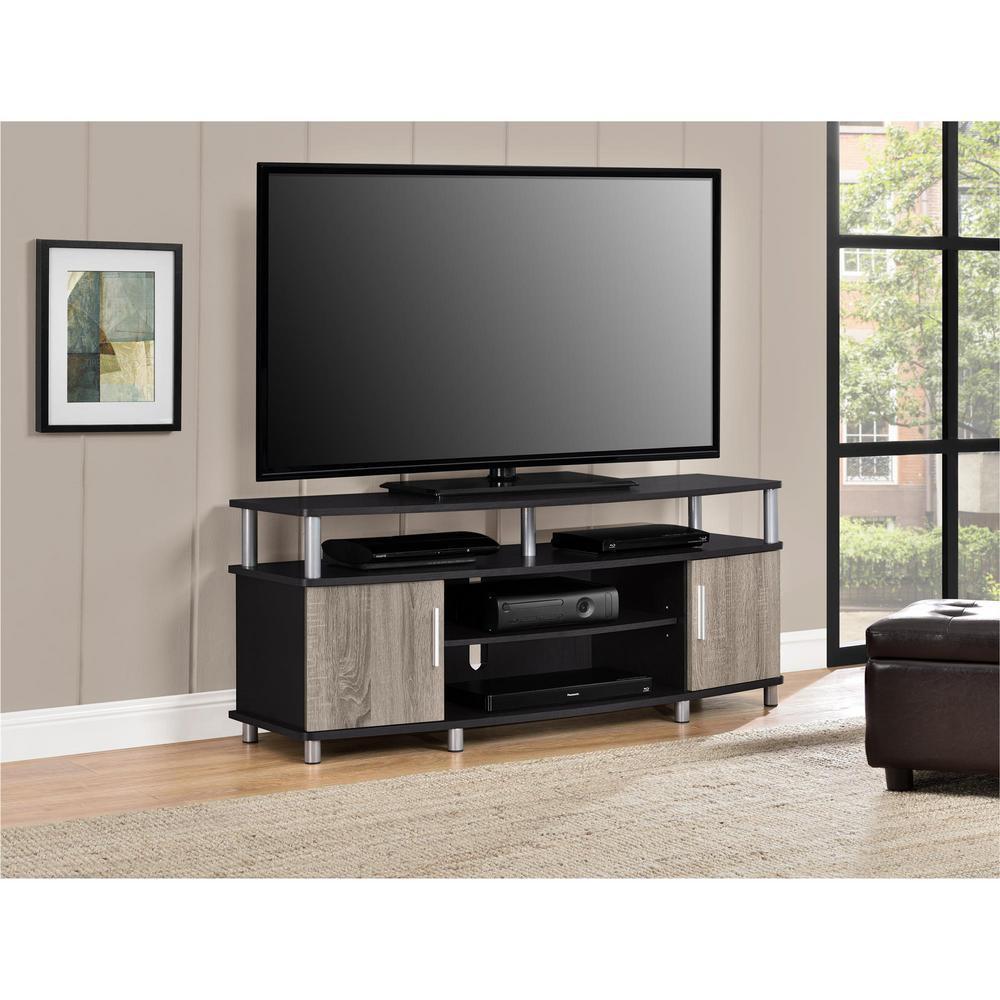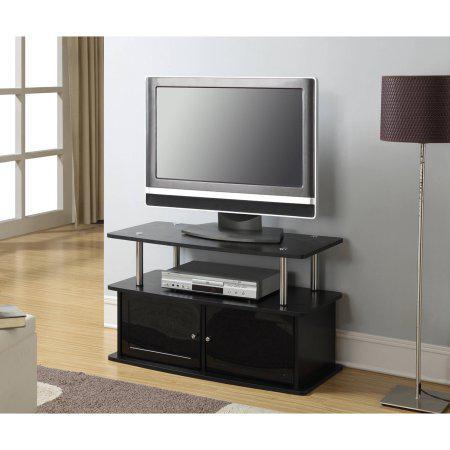The first image is the image on the left, the second image is the image on the right. For the images shown, is this caption "Only one of the televisions appears to be reflecting light; the other tv is completely dark." true? Answer yes or no. No. 